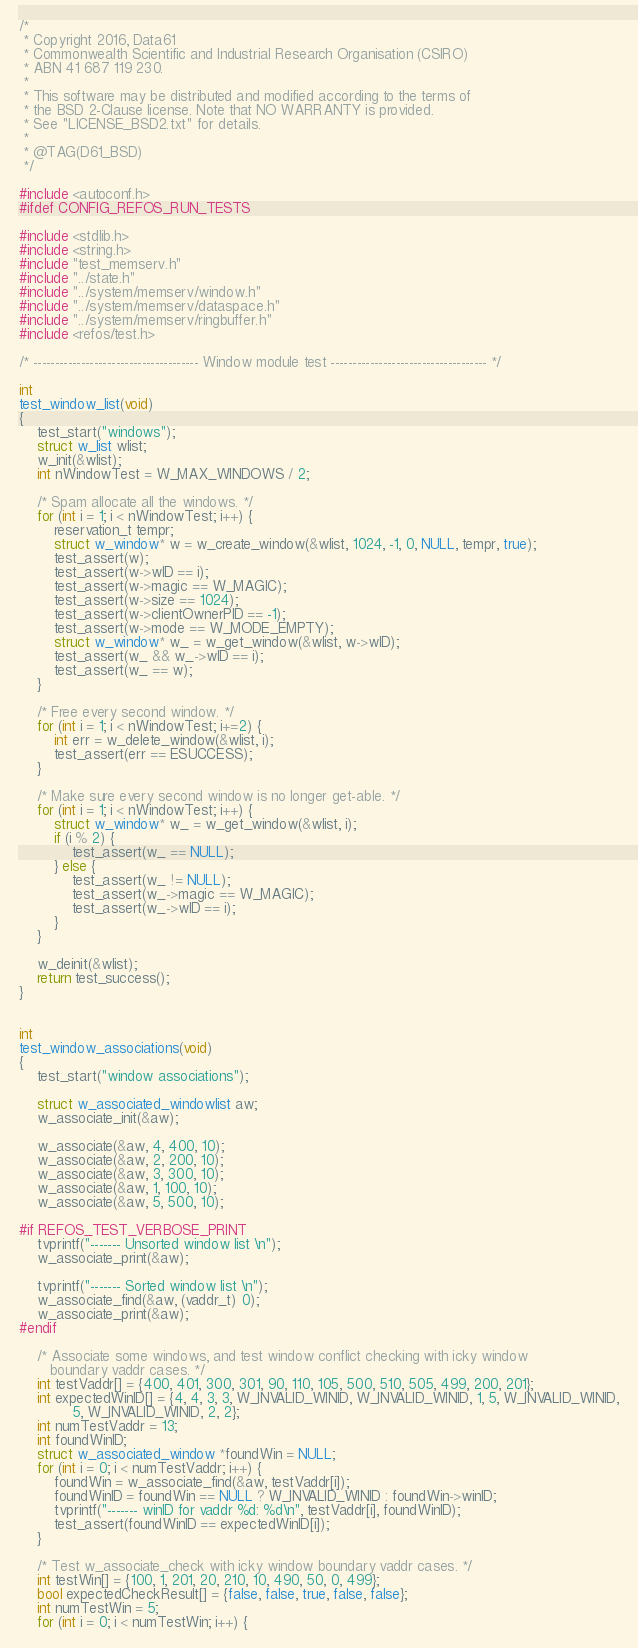<code> <loc_0><loc_0><loc_500><loc_500><_C_>/*
 * Copyright 2016, Data61
 * Commonwealth Scientific and Industrial Research Organisation (CSIRO)
 * ABN 41 687 119 230.
 *
 * This software may be distributed and modified according to the terms of
 * the BSD 2-Clause license. Note that NO WARRANTY is provided.
 * See "LICENSE_BSD2.txt" for details.
 *
 * @TAG(D61_BSD)
 */

#include <autoconf.h>
#ifdef CONFIG_REFOS_RUN_TESTS

#include <stdlib.h>
#include <string.h>
#include "test_memserv.h"
#include "../state.h"
#include "../system/memserv/window.h"
#include "../system/memserv/dataspace.h"
#include "../system/memserv/ringbuffer.h"
#include <refos/test.h>

/* -------------------------------------- Window module test ------------------------------------ */

int
test_window_list(void)
{
    test_start("windows");
    struct w_list wlist;
    w_init(&wlist);
    int nWindowTest = W_MAX_WINDOWS / 2;

    /* Spam allocate all the windows. */
    for (int i = 1; i < nWindowTest; i++) {
        reservation_t tempr;
        struct w_window* w = w_create_window(&wlist, 1024, -1, 0, NULL, tempr, true);
        test_assert(w);
        test_assert(w->wID == i);
        test_assert(w->magic == W_MAGIC);
        test_assert(w->size == 1024);
        test_assert(w->clientOwnerPID == -1);
        test_assert(w->mode == W_MODE_EMPTY);
        struct w_window* w_ = w_get_window(&wlist, w->wID);
        test_assert(w_ && w_->wID == i);
        test_assert(w_ == w);
    }

    /* Free every second window. */
    for (int i = 1; i < nWindowTest; i+=2) {
        int err = w_delete_window(&wlist, i);
        test_assert(err == ESUCCESS);
    }

    /* Make sure every second window is no longer get-able. */
    for (int i = 1; i < nWindowTest; i++) {
        struct w_window* w_ = w_get_window(&wlist, i);
        if (i % 2) {
            test_assert(w_ == NULL);
        } else {
            test_assert(w_ != NULL);
            test_assert(w_->magic == W_MAGIC);
            test_assert(w_->wID == i);
        }
    }

    w_deinit(&wlist);
    return test_success();
}


int
test_window_associations(void)
{
    test_start("window associations");

    struct w_associated_windowlist aw;
    w_associate_init(&aw);
    
    w_associate(&aw, 4, 400, 10);
    w_associate(&aw, 2, 200, 10);
    w_associate(&aw, 3, 300, 10);
    w_associate(&aw, 1, 100, 10);
    w_associate(&aw, 5, 500, 10);
    
#if REFOS_TEST_VERBOSE_PRINT
    tvprintf("------- Unsorted window list \n");
    w_associate_print(&aw);
    
    tvprintf("------- Sorted window list \n");
    w_associate_find(&aw, (vaddr_t) 0);
    w_associate_print(&aw);
#endif
    
    /* Associate some windows, and test window conflict checking with icky window
       boundary vaddr cases. */
    int testVaddr[] = {400, 401, 300, 301, 90, 110, 105, 500, 510, 505, 499, 200, 201};
    int expectedWinID[] = {4, 4, 3, 3, W_INVALID_WINID, W_INVALID_WINID, 1, 5, W_INVALID_WINID,
            5, W_INVALID_WINID, 2, 2};
    int numTestVaddr = 13;
    int foundWinID;
    struct w_associated_window *foundWin = NULL;
    for (int i = 0; i < numTestVaddr; i++) {
        foundWin = w_associate_find(&aw, testVaddr[i]);
        foundWinID = foundWin == NULL ? W_INVALID_WINID : foundWin->winID;
        tvprintf("------- winID for vaddr %d: %d\n", testVaddr[i], foundWinID);
        test_assert(foundWinID == expectedWinID[i]);
    }
    
    /* Test w_associate_check with icky window boundary vaddr cases. */
    int testWin[] = {100, 1, 201, 20, 210, 10, 490, 50, 0, 499};
    bool expectedCheckResult[] = {false, false, true, false, false};
    int numTestWin = 5;
    for (int i = 0; i < numTestWin; i++) {</code> 